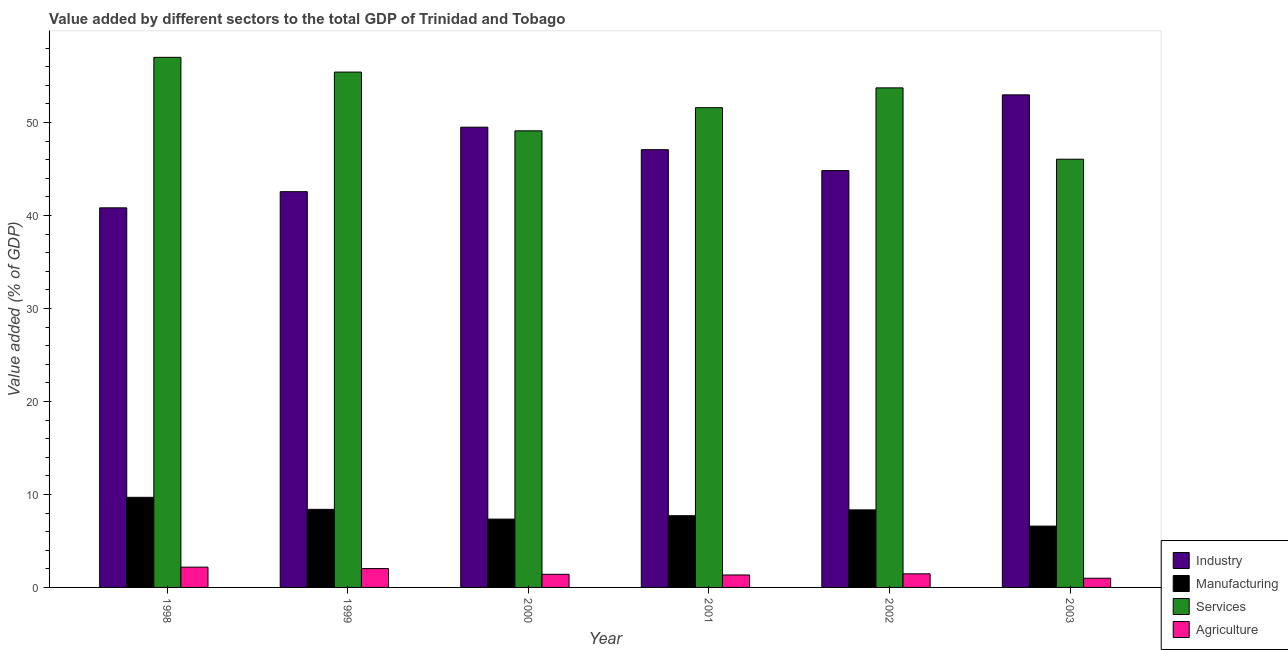How many different coloured bars are there?
Provide a succinct answer. 4. How many groups of bars are there?
Offer a very short reply. 6. Are the number of bars per tick equal to the number of legend labels?
Your response must be concise. Yes. Are the number of bars on each tick of the X-axis equal?
Your response must be concise. Yes. How many bars are there on the 3rd tick from the left?
Provide a succinct answer. 4. How many bars are there on the 3rd tick from the right?
Keep it short and to the point. 4. What is the label of the 1st group of bars from the left?
Your answer should be very brief. 1998. In how many cases, is the number of bars for a given year not equal to the number of legend labels?
Give a very brief answer. 0. What is the value added by agricultural sector in 1998?
Keep it short and to the point. 2.18. Across all years, what is the maximum value added by manufacturing sector?
Give a very brief answer. 9.69. Across all years, what is the minimum value added by services sector?
Give a very brief answer. 46.05. What is the total value added by manufacturing sector in the graph?
Provide a short and direct response. 48.08. What is the difference between the value added by agricultural sector in 2000 and that in 2002?
Your answer should be compact. -0.05. What is the difference between the value added by manufacturing sector in 2001 and the value added by services sector in 2000?
Provide a succinct answer. 0.37. What is the average value added by agricultural sector per year?
Offer a terse response. 1.57. In how many years, is the value added by agricultural sector greater than 34 %?
Offer a terse response. 0. What is the ratio of the value added by services sector in 1999 to that in 2003?
Keep it short and to the point. 1.2. Is the value added by industrial sector in 1999 less than that in 2001?
Your answer should be compact. Yes. What is the difference between the highest and the second highest value added by industrial sector?
Ensure brevity in your answer.  3.48. What is the difference between the highest and the lowest value added by services sector?
Provide a succinct answer. 10.96. Is it the case that in every year, the sum of the value added by industrial sector and value added by manufacturing sector is greater than the sum of value added by services sector and value added by agricultural sector?
Your answer should be very brief. Yes. What does the 1st bar from the left in 1998 represents?
Keep it short and to the point. Industry. What does the 3rd bar from the right in 1998 represents?
Ensure brevity in your answer.  Manufacturing. Is it the case that in every year, the sum of the value added by industrial sector and value added by manufacturing sector is greater than the value added by services sector?
Ensure brevity in your answer.  No. How many bars are there?
Keep it short and to the point. 24. Are all the bars in the graph horizontal?
Give a very brief answer. No. How many years are there in the graph?
Your response must be concise. 6. Are the values on the major ticks of Y-axis written in scientific E-notation?
Your answer should be very brief. No. Does the graph contain any zero values?
Offer a very short reply. No. Does the graph contain grids?
Give a very brief answer. No. How are the legend labels stacked?
Make the answer very short. Vertical. What is the title of the graph?
Your answer should be compact. Value added by different sectors to the total GDP of Trinidad and Tobago. What is the label or title of the Y-axis?
Provide a short and direct response. Value added (% of GDP). What is the Value added (% of GDP) in Industry in 1998?
Make the answer very short. 40.82. What is the Value added (% of GDP) in Manufacturing in 1998?
Offer a very short reply. 9.69. What is the Value added (% of GDP) of Services in 1998?
Your response must be concise. 57. What is the Value added (% of GDP) of Agriculture in 1998?
Keep it short and to the point. 2.18. What is the Value added (% of GDP) of Industry in 1999?
Your answer should be very brief. 42.56. What is the Value added (% of GDP) of Manufacturing in 1999?
Ensure brevity in your answer.  8.4. What is the Value added (% of GDP) of Services in 1999?
Give a very brief answer. 55.42. What is the Value added (% of GDP) of Agriculture in 1999?
Offer a very short reply. 2.03. What is the Value added (% of GDP) in Industry in 2000?
Your answer should be very brief. 49.49. What is the Value added (% of GDP) in Manufacturing in 2000?
Ensure brevity in your answer.  7.35. What is the Value added (% of GDP) of Services in 2000?
Your answer should be compact. 49.1. What is the Value added (% of GDP) of Agriculture in 2000?
Ensure brevity in your answer.  1.41. What is the Value added (% of GDP) in Industry in 2001?
Make the answer very short. 47.07. What is the Value added (% of GDP) of Manufacturing in 2001?
Offer a very short reply. 7.71. What is the Value added (% of GDP) of Services in 2001?
Provide a short and direct response. 51.59. What is the Value added (% of GDP) in Agriculture in 2001?
Your answer should be compact. 1.34. What is the Value added (% of GDP) of Industry in 2002?
Offer a terse response. 44.82. What is the Value added (% of GDP) of Manufacturing in 2002?
Your answer should be very brief. 8.34. What is the Value added (% of GDP) of Services in 2002?
Make the answer very short. 53.72. What is the Value added (% of GDP) in Agriculture in 2002?
Provide a succinct answer. 1.46. What is the Value added (% of GDP) in Industry in 2003?
Ensure brevity in your answer.  52.97. What is the Value added (% of GDP) in Manufacturing in 2003?
Keep it short and to the point. 6.59. What is the Value added (% of GDP) in Services in 2003?
Your answer should be very brief. 46.05. What is the Value added (% of GDP) in Agriculture in 2003?
Keep it short and to the point. 0.99. Across all years, what is the maximum Value added (% of GDP) of Industry?
Offer a terse response. 52.97. Across all years, what is the maximum Value added (% of GDP) of Manufacturing?
Your answer should be very brief. 9.69. Across all years, what is the maximum Value added (% of GDP) of Services?
Keep it short and to the point. 57. Across all years, what is the maximum Value added (% of GDP) in Agriculture?
Make the answer very short. 2.18. Across all years, what is the minimum Value added (% of GDP) in Industry?
Provide a succinct answer. 40.82. Across all years, what is the minimum Value added (% of GDP) of Manufacturing?
Your answer should be very brief. 6.59. Across all years, what is the minimum Value added (% of GDP) in Services?
Provide a succinct answer. 46.05. Across all years, what is the minimum Value added (% of GDP) of Agriculture?
Ensure brevity in your answer.  0.99. What is the total Value added (% of GDP) in Industry in the graph?
Make the answer very short. 277.72. What is the total Value added (% of GDP) in Manufacturing in the graph?
Keep it short and to the point. 48.08. What is the total Value added (% of GDP) of Services in the graph?
Your answer should be very brief. 312.87. What is the total Value added (% of GDP) in Agriculture in the graph?
Make the answer very short. 9.41. What is the difference between the Value added (% of GDP) in Industry in 1998 and that in 1999?
Your answer should be compact. -1.74. What is the difference between the Value added (% of GDP) in Manufacturing in 1998 and that in 1999?
Your response must be concise. 1.29. What is the difference between the Value added (% of GDP) in Services in 1998 and that in 1999?
Offer a terse response. 1.59. What is the difference between the Value added (% of GDP) in Agriculture in 1998 and that in 1999?
Your answer should be very brief. 0.15. What is the difference between the Value added (% of GDP) of Industry in 1998 and that in 2000?
Keep it short and to the point. -8.67. What is the difference between the Value added (% of GDP) in Manufacturing in 1998 and that in 2000?
Offer a very short reply. 2.34. What is the difference between the Value added (% of GDP) in Services in 1998 and that in 2000?
Give a very brief answer. 7.9. What is the difference between the Value added (% of GDP) in Agriculture in 1998 and that in 2000?
Your answer should be very brief. 0.77. What is the difference between the Value added (% of GDP) in Industry in 1998 and that in 2001?
Your answer should be very brief. -6.25. What is the difference between the Value added (% of GDP) in Manufacturing in 1998 and that in 2001?
Your answer should be compact. 1.98. What is the difference between the Value added (% of GDP) in Services in 1998 and that in 2001?
Make the answer very short. 5.41. What is the difference between the Value added (% of GDP) of Agriculture in 1998 and that in 2001?
Your answer should be very brief. 0.84. What is the difference between the Value added (% of GDP) of Industry in 1998 and that in 2002?
Provide a succinct answer. -4. What is the difference between the Value added (% of GDP) in Manufacturing in 1998 and that in 2002?
Make the answer very short. 1.35. What is the difference between the Value added (% of GDP) of Services in 1998 and that in 2002?
Provide a succinct answer. 3.28. What is the difference between the Value added (% of GDP) of Agriculture in 1998 and that in 2002?
Give a very brief answer. 0.72. What is the difference between the Value added (% of GDP) in Industry in 1998 and that in 2003?
Keep it short and to the point. -12.15. What is the difference between the Value added (% of GDP) of Manufacturing in 1998 and that in 2003?
Ensure brevity in your answer.  3.09. What is the difference between the Value added (% of GDP) of Services in 1998 and that in 2003?
Make the answer very short. 10.96. What is the difference between the Value added (% of GDP) in Agriculture in 1998 and that in 2003?
Your answer should be very brief. 1.19. What is the difference between the Value added (% of GDP) of Industry in 1999 and that in 2000?
Your answer should be very brief. -6.93. What is the difference between the Value added (% of GDP) in Manufacturing in 1999 and that in 2000?
Provide a succinct answer. 1.05. What is the difference between the Value added (% of GDP) of Services in 1999 and that in 2000?
Provide a succinct answer. 6.32. What is the difference between the Value added (% of GDP) in Agriculture in 1999 and that in 2000?
Make the answer very short. 0.61. What is the difference between the Value added (% of GDP) in Industry in 1999 and that in 2001?
Ensure brevity in your answer.  -4.51. What is the difference between the Value added (% of GDP) in Manufacturing in 1999 and that in 2001?
Make the answer very short. 0.68. What is the difference between the Value added (% of GDP) of Services in 1999 and that in 2001?
Your answer should be compact. 3.83. What is the difference between the Value added (% of GDP) in Agriculture in 1999 and that in 2001?
Your answer should be compact. 0.69. What is the difference between the Value added (% of GDP) of Industry in 1999 and that in 2002?
Your answer should be very brief. -2.26. What is the difference between the Value added (% of GDP) of Manufacturing in 1999 and that in 2002?
Offer a terse response. 0.06. What is the difference between the Value added (% of GDP) of Services in 1999 and that in 2002?
Offer a very short reply. 1.7. What is the difference between the Value added (% of GDP) in Agriculture in 1999 and that in 2002?
Your response must be concise. 0.57. What is the difference between the Value added (% of GDP) of Industry in 1999 and that in 2003?
Keep it short and to the point. -10.41. What is the difference between the Value added (% of GDP) of Manufacturing in 1999 and that in 2003?
Offer a very short reply. 1.8. What is the difference between the Value added (% of GDP) in Services in 1999 and that in 2003?
Your response must be concise. 9.37. What is the difference between the Value added (% of GDP) of Agriculture in 1999 and that in 2003?
Your response must be concise. 1.04. What is the difference between the Value added (% of GDP) of Industry in 2000 and that in 2001?
Make the answer very short. 2.42. What is the difference between the Value added (% of GDP) in Manufacturing in 2000 and that in 2001?
Provide a short and direct response. -0.37. What is the difference between the Value added (% of GDP) of Services in 2000 and that in 2001?
Keep it short and to the point. -2.49. What is the difference between the Value added (% of GDP) in Agriculture in 2000 and that in 2001?
Ensure brevity in your answer.  0.07. What is the difference between the Value added (% of GDP) of Industry in 2000 and that in 2002?
Your response must be concise. 4.67. What is the difference between the Value added (% of GDP) in Manufacturing in 2000 and that in 2002?
Offer a very short reply. -0.99. What is the difference between the Value added (% of GDP) in Services in 2000 and that in 2002?
Provide a short and direct response. -4.62. What is the difference between the Value added (% of GDP) in Agriculture in 2000 and that in 2002?
Make the answer very short. -0.05. What is the difference between the Value added (% of GDP) in Industry in 2000 and that in 2003?
Your answer should be very brief. -3.48. What is the difference between the Value added (% of GDP) of Manufacturing in 2000 and that in 2003?
Provide a succinct answer. 0.75. What is the difference between the Value added (% of GDP) of Services in 2000 and that in 2003?
Your answer should be compact. 3.05. What is the difference between the Value added (% of GDP) of Agriculture in 2000 and that in 2003?
Offer a terse response. 0.43. What is the difference between the Value added (% of GDP) in Industry in 2001 and that in 2002?
Provide a succinct answer. 2.25. What is the difference between the Value added (% of GDP) in Manufacturing in 2001 and that in 2002?
Your answer should be compact. -0.63. What is the difference between the Value added (% of GDP) in Services in 2001 and that in 2002?
Your response must be concise. -2.13. What is the difference between the Value added (% of GDP) in Agriculture in 2001 and that in 2002?
Ensure brevity in your answer.  -0.12. What is the difference between the Value added (% of GDP) of Industry in 2001 and that in 2003?
Your answer should be compact. -5.9. What is the difference between the Value added (% of GDP) of Manufacturing in 2001 and that in 2003?
Make the answer very short. 1.12. What is the difference between the Value added (% of GDP) in Services in 2001 and that in 2003?
Keep it short and to the point. 5.54. What is the difference between the Value added (% of GDP) in Agriculture in 2001 and that in 2003?
Your response must be concise. 0.35. What is the difference between the Value added (% of GDP) of Industry in 2002 and that in 2003?
Ensure brevity in your answer.  -8.15. What is the difference between the Value added (% of GDP) in Manufacturing in 2002 and that in 2003?
Keep it short and to the point. 1.75. What is the difference between the Value added (% of GDP) of Services in 2002 and that in 2003?
Provide a short and direct response. 7.67. What is the difference between the Value added (% of GDP) of Agriculture in 2002 and that in 2003?
Offer a terse response. 0.47. What is the difference between the Value added (% of GDP) of Industry in 1998 and the Value added (% of GDP) of Manufacturing in 1999?
Your answer should be very brief. 32.42. What is the difference between the Value added (% of GDP) in Industry in 1998 and the Value added (% of GDP) in Services in 1999?
Your response must be concise. -14.6. What is the difference between the Value added (% of GDP) of Industry in 1998 and the Value added (% of GDP) of Agriculture in 1999?
Your answer should be compact. 38.79. What is the difference between the Value added (% of GDP) in Manufacturing in 1998 and the Value added (% of GDP) in Services in 1999?
Provide a short and direct response. -45.73. What is the difference between the Value added (% of GDP) of Manufacturing in 1998 and the Value added (% of GDP) of Agriculture in 1999?
Keep it short and to the point. 7.66. What is the difference between the Value added (% of GDP) in Services in 1998 and the Value added (% of GDP) in Agriculture in 1999?
Provide a short and direct response. 54.97. What is the difference between the Value added (% of GDP) of Industry in 1998 and the Value added (% of GDP) of Manufacturing in 2000?
Offer a very short reply. 33.47. What is the difference between the Value added (% of GDP) of Industry in 1998 and the Value added (% of GDP) of Services in 2000?
Keep it short and to the point. -8.28. What is the difference between the Value added (% of GDP) of Industry in 1998 and the Value added (% of GDP) of Agriculture in 2000?
Your response must be concise. 39.4. What is the difference between the Value added (% of GDP) of Manufacturing in 1998 and the Value added (% of GDP) of Services in 2000?
Your response must be concise. -39.41. What is the difference between the Value added (% of GDP) in Manufacturing in 1998 and the Value added (% of GDP) in Agriculture in 2000?
Make the answer very short. 8.28. What is the difference between the Value added (% of GDP) in Services in 1998 and the Value added (% of GDP) in Agriculture in 2000?
Your response must be concise. 55.59. What is the difference between the Value added (% of GDP) of Industry in 1998 and the Value added (% of GDP) of Manufacturing in 2001?
Your answer should be very brief. 33.1. What is the difference between the Value added (% of GDP) in Industry in 1998 and the Value added (% of GDP) in Services in 2001?
Make the answer very short. -10.77. What is the difference between the Value added (% of GDP) in Industry in 1998 and the Value added (% of GDP) in Agriculture in 2001?
Make the answer very short. 39.48. What is the difference between the Value added (% of GDP) of Manufacturing in 1998 and the Value added (% of GDP) of Services in 2001?
Keep it short and to the point. -41.9. What is the difference between the Value added (% of GDP) of Manufacturing in 1998 and the Value added (% of GDP) of Agriculture in 2001?
Your response must be concise. 8.35. What is the difference between the Value added (% of GDP) in Services in 1998 and the Value added (% of GDP) in Agriculture in 2001?
Make the answer very short. 55.66. What is the difference between the Value added (% of GDP) of Industry in 1998 and the Value added (% of GDP) of Manufacturing in 2002?
Your answer should be compact. 32.48. What is the difference between the Value added (% of GDP) of Industry in 1998 and the Value added (% of GDP) of Services in 2002?
Keep it short and to the point. -12.9. What is the difference between the Value added (% of GDP) of Industry in 1998 and the Value added (% of GDP) of Agriculture in 2002?
Provide a succinct answer. 39.36. What is the difference between the Value added (% of GDP) in Manufacturing in 1998 and the Value added (% of GDP) in Services in 2002?
Ensure brevity in your answer.  -44.03. What is the difference between the Value added (% of GDP) in Manufacturing in 1998 and the Value added (% of GDP) in Agriculture in 2002?
Keep it short and to the point. 8.23. What is the difference between the Value added (% of GDP) in Services in 1998 and the Value added (% of GDP) in Agriculture in 2002?
Offer a very short reply. 55.54. What is the difference between the Value added (% of GDP) in Industry in 1998 and the Value added (% of GDP) in Manufacturing in 2003?
Keep it short and to the point. 34.22. What is the difference between the Value added (% of GDP) in Industry in 1998 and the Value added (% of GDP) in Services in 2003?
Your answer should be compact. -5.23. What is the difference between the Value added (% of GDP) of Industry in 1998 and the Value added (% of GDP) of Agriculture in 2003?
Provide a short and direct response. 39.83. What is the difference between the Value added (% of GDP) in Manufacturing in 1998 and the Value added (% of GDP) in Services in 2003?
Make the answer very short. -36.36. What is the difference between the Value added (% of GDP) of Manufacturing in 1998 and the Value added (% of GDP) of Agriculture in 2003?
Offer a very short reply. 8.7. What is the difference between the Value added (% of GDP) in Services in 1998 and the Value added (% of GDP) in Agriculture in 2003?
Your response must be concise. 56.01. What is the difference between the Value added (% of GDP) in Industry in 1999 and the Value added (% of GDP) in Manufacturing in 2000?
Offer a very short reply. 35.21. What is the difference between the Value added (% of GDP) of Industry in 1999 and the Value added (% of GDP) of Services in 2000?
Give a very brief answer. -6.54. What is the difference between the Value added (% of GDP) of Industry in 1999 and the Value added (% of GDP) of Agriculture in 2000?
Your answer should be very brief. 41.14. What is the difference between the Value added (% of GDP) of Manufacturing in 1999 and the Value added (% of GDP) of Services in 2000?
Your answer should be compact. -40.7. What is the difference between the Value added (% of GDP) in Manufacturing in 1999 and the Value added (% of GDP) in Agriculture in 2000?
Make the answer very short. 6.98. What is the difference between the Value added (% of GDP) of Services in 1999 and the Value added (% of GDP) of Agriculture in 2000?
Your answer should be very brief. 54. What is the difference between the Value added (% of GDP) in Industry in 1999 and the Value added (% of GDP) in Manufacturing in 2001?
Provide a succinct answer. 34.84. What is the difference between the Value added (% of GDP) in Industry in 1999 and the Value added (% of GDP) in Services in 2001?
Your answer should be compact. -9.03. What is the difference between the Value added (% of GDP) in Industry in 1999 and the Value added (% of GDP) in Agriculture in 2001?
Provide a short and direct response. 41.22. What is the difference between the Value added (% of GDP) in Manufacturing in 1999 and the Value added (% of GDP) in Services in 2001?
Offer a very short reply. -43.19. What is the difference between the Value added (% of GDP) of Manufacturing in 1999 and the Value added (% of GDP) of Agriculture in 2001?
Provide a succinct answer. 7.06. What is the difference between the Value added (% of GDP) of Services in 1999 and the Value added (% of GDP) of Agriculture in 2001?
Your answer should be compact. 54.08. What is the difference between the Value added (% of GDP) in Industry in 1999 and the Value added (% of GDP) in Manufacturing in 2002?
Provide a short and direct response. 34.22. What is the difference between the Value added (% of GDP) of Industry in 1999 and the Value added (% of GDP) of Services in 2002?
Ensure brevity in your answer.  -11.16. What is the difference between the Value added (% of GDP) of Industry in 1999 and the Value added (% of GDP) of Agriculture in 2002?
Offer a very short reply. 41.1. What is the difference between the Value added (% of GDP) of Manufacturing in 1999 and the Value added (% of GDP) of Services in 2002?
Give a very brief answer. -45.32. What is the difference between the Value added (% of GDP) in Manufacturing in 1999 and the Value added (% of GDP) in Agriculture in 2002?
Make the answer very short. 6.93. What is the difference between the Value added (% of GDP) of Services in 1999 and the Value added (% of GDP) of Agriculture in 2002?
Ensure brevity in your answer.  53.95. What is the difference between the Value added (% of GDP) in Industry in 1999 and the Value added (% of GDP) in Manufacturing in 2003?
Provide a short and direct response. 35.96. What is the difference between the Value added (% of GDP) of Industry in 1999 and the Value added (% of GDP) of Services in 2003?
Provide a short and direct response. -3.49. What is the difference between the Value added (% of GDP) of Industry in 1999 and the Value added (% of GDP) of Agriculture in 2003?
Provide a short and direct response. 41.57. What is the difference between the Value added (% of GDP) of Manufacturing in 1999 and the Value added (% of GDP) of Services in 2003?
Your answer should be compact. -37.65. What is the difference between the Value added (% of GDP) in Manufacturing in 1999 and the Value added (% of GDP) in Agriculture in 2003?
Provide a succinct answer. 7.41. What is the difference between the Value added (% of GDP) of Services in 1999 and the Value added (% of GDP) of Agriculture in 2003?
Provide a succinct answer. 54.43. What is the difference between the Value added (% of GDP) of Industry in 2000 and the Value added (% of GDP) of Manufacturing in 2001?
Provide a short and direct response. 41.78. What is the difference between the Value added (% of GDP) of Industry in 2000 and the Value added (% of GDP) of Services in 2001?
Offer a terse response. -2.1. What is the difference between the Value added (% of GDP) of Industry in 2000 and the Value added (% of GDP) of Agriculture in 2001?
Ensure brevity in your answer.  48.15. What is the difference between the Value added (% of GDP) in Manufacturing in 2000 and the Value added (% of GDP) in Services in 2001?
Provide a short and direct response. -44.24. What is the difference between the Value added (% of GDP) of Manufacturing in 2000 and the Value added (% of GDP) of Agriculture in 2001?
Give a very brief answer. 6.01. What is the difference between the Value added (% of GDP) of Services in 2000 and the Value added (% of GDP) of Agriculture in 2001?
Provide a short and direct response. 47.76. What is the difference between the Value added (% of GDP) of Industry in 2000 and the Value added (% of GDP) of Manufacturing in 2002?
Make the answer very short. 41.15. What is the difference between the Value added (% of GDP) of Industry in 2000 and the Value added (% of GDP) of Services in 2002?
Offer a terse response. -4.23. What is the difference between the Value added (% of GDP) in Industry in 2000 and the Value added (% of GDP) in Agriculture in 2002?
Ensure brevity in your answer.  48.03. What is the difference between the Value added (% of GDP) in Manufacturing in 2000 and the Value added (% of GDP) in Services in 2002?
Your answer should be very brief. -46.37. What is the difference between the Value added (% of GDP) in Manufacturing in 2000 and the Value added (% of GDP) in Agriculture in 2002?
Offer a terse response. 5.89. What is the difference between the Value added (% of GDP) in Services in 2000 and the Value added (% of GDP) in Agriculture in 2002?
Offer a very short reply. 47.64. What is the difference between the Value added (% of GDP) of Industry in 2000 and the Value added (% of GDP) of Manufacturing in 2003?
Make the answer very short. 42.9. What is the difference between the Value added (% of GDP) in Industry in 2000 and the Value added (% of GDP) in Services in 2003?
Your response must be concise. 3.44. What is the difference between the Value added (% of GDP) of Industry in 2000 and the Value added (% of GDP) of Agriculture in 2003?
Your response must be concise. 48.5. What is the difference between the Value added (% of GDP) in Manufacturing in 2000 and the Value added (% of GDP) in Services in 2003?
Give a very brief answer. -38.7. What is the difference between the Value added (% of GDP) of Manufacturing in 2000 and the Value added (% of GDP) of Agriculture in 2003?
Your answer should be compact. 6.36. What is the difference between the Value added (% of GDP) of Services in 2000 and the Value added (% of GDP) of Agriculture in 2003?
Your answer should be very brief. 48.11. What is the difference between the Value added (% of GDP) in Industry in 2001 and the Value added (% of GDP) in Manufacturing in 2002?
Offer a terse response. 38.73. What is the difference between the Value added (% of GDP) of Industry in 2001 and the Value added (% of GDP) of Services in 2002?
Keep it short and to the point. -6.65. What is the difference between the Value added (% of GDP) in Industry in 2001 and the Value added (% of GDP) in Agriculture in 2002?
Keep it short and to the point. 45.61. What is the difference between the Value added (% of GDP) in Manufacturing in 2001 and the Value added (% of GDP) in Services in 2002?
Give a very brief answer. -46.01. What is the difference between the Value added (% of GDP) in Manufacturing in 2001 and the Value added (% of GDP) in Agriculture in 2002?
Provide a short and direct response. 6.25. What is the difference between the Value added (% of GDP) of Services in 2001 and the Value added (% of GDP) of Agriculture in 2002?
Offer a very short reply. 50.13. What is the difference between the Value added (% of GDP) in Industry in 2001 and the Value added (% of GDP) in Manufacturing in 2003?
Your answer should be compact. 40.48. What is the difference between the Value added (% of GDP) of Industry in 2001 and the Value added (% of GDP) of Services in 2003?
Give a very brief answer. 1.03. What is the difference between the Value added (% of GDP) of Industry in 2001 and the Value added (% of GDP) of Agriculture in 2003?
Offer a terse response. 46.08. What is the difference between the Value added (% of GDP) of Manufacturing in 2001 and the Value added (% of GDP) of Services in 2003?
Your answer should be very brief. -38.33. What is the difference between the Value added (% of GDP) in Manufacturing in 2001 and the Value added (% of GDP) in Agriculture in 2003?
Ensure brevity in your answer.  6.73. What is the difference between the Value added (% of GDP) of Services in 2001 and the Value added (% of GDP) of Agriculture in 2003?
Your response must be concise. 50.6. What is the difference between the Value added (% of GDP) of Industry in 2002 and the Value added (% of GDP) of Manufacturing in 2003?
Offer a terse response. 38.23. What is the difference between the Value added (% of GDP) of Industry in 2002 and the Value added (% of GDP) of Services in 2003?
Provide a succinct answer. -1.22. What is the difference between the Value added (% of GDP) in Industry in 2002 and the Value added (% of GDP) in Agriculture in 2003?
Your response must be concise. 43.83. What is the difference between the Value added (% of GDP) in Manufacturing in 2002 and the Value added (% of GDP) in Services in 2003?
Your response must be concise. -37.71. What is the difference between the Value added (% of GDP) in Manufacturing in 2002 and the Value added (% of GDP) in Agriculture in 2003?
Provide a succinct answer. 7.35. What is the difference between the Value added (% of GDP) in Services in 2002 and the Value added (% of GDP) in Agriculture in 2003?
Provide a succinct answer. 52.73. What is the average Value added (% of GDP) of Industry per year?
Offer a terse response. 46.29. What is the average Value added (% of GDP) in Manufacturing per year?
Offer a terse response. 8.01. What is the average Value added (% of GDP) in Services per year?
Keep it short and to the point. 52.14. What is the average Value added (% of GDP) in Agriculture per year?
Offer a terse response. 1.57. In the year 1998, what is the difference between the Value added (% of GDP) of Industry and Value added (% of GDP) of Manufacturing?
Make the answer very short. 31.13. In the year 1998, what is the difference between the Value added (% of GDP) in Industry and Value added (% of GDP) in Services?
Make the answer very short. -16.18. In the year 1998, what is the difference between the Value added (% of GDP) of Industry and Value added (% of GDP) of Agriculture?
Your answer should be very brief. 38.64. In the year 1998, what is the difference between the Value added (% of GDP) in Manufacturing and Value added (% of GDP) in Services?
Offer a very short reply. -47.31. In the year 1998, what is the difference between the Value added (% of GDP) of Manufacturing and Value added (% of GDP) of Agriculture?
Provide a succinct answer. 7.51. In the year 1998, what is the difference between the Value added (% of GDP) in Services and Value added (% of GDP) in Agriculture?
Provide a succinct answer. 54.82. In the year 1999, what is the difference between the Value added (% of GDP) in Industry and Value added (% of GDP) in Manufacturing?
Ensure brevity in your answer.  34.16. In the year 1999, what is the difference between the Value added (% of GDP) in Industry and Value added (% of GDP) in Services?
Ensure brevity in your answer.  -12.86. In the year 1999, what is the difference between the Value added (% of GDP) in Industry and Value added (% of GDP) in Agriculture?
Provide a short and direct response. 40.53. In the year 1999, what is the difference between the Value added (% of GDP) in Manufacturing and Value added (% of GDP) in Services?
Provide a short and direct response. -47.02. In the year 1999, what is the difference between the Value added (% of GDP) in Manufacturing and Value added (% of GDP) in Agriculture?
Make the answer very short. 6.37. In the year 1999, what is the difference between the Value added (% of GDP) in Services and Value added (% of GDP) in Agriculture?
Provide a short and direct response. 53.39. In the year 2000, what is the difference between the Value added (% of GDP) of Industry and Value added (% of GDP) of Manufacturing?
Ensure brevity in your answer.  42.14. In the year 2000, what is the difference between the Value added (% of GDP) in Industry and Value added (% of GDP) in Services?
Offer a terse response. 0.39. In the year 2000, what is the difference between the Value added (% of GDP) of Industry and Value added (% of GDP) of Agriculture?
Make the answer very short. 48.08. In the year 2000, what is the difference between the Value added (% of GDP) of Manufacturing and Value added (% of GDP) of Services?
Provide a succinct answer. -41.75. In the year 2000, what is the difference between the Value added (% of GDP) of Manufacturing and Value added (% of GDP) of Agriculture?
Give a very brief answer. 5.93. In the year 2000, what is the difference between the Value added (% of GDP) in Services and Value added (% of GDP) in Agriculture?
Provide a short and direct response. 47.69. In the year 2001, what is the difference between the Value added (% of GDP) of Industry and Value added (% of GDP) of Manufacturing?
Your answer should be compact. 39.36. In the year 2001, what is the difference between the Value added (% of GDP) of Industry and Value added (% of GDP) of Services?
Offer a very short reply. -4.52. In the year 2001, what is the difference between the Value added (% of GDP) in Industry and Value added (% of GDP) in Agriculture?
Provide a short and direct response. 45.73. In the year 2001, what is the difference between the Value added (% of GDP) of Manufacturing and Value added (% of GDP) of Services?
Keep it short and to the point. -43.88. In the year 2001, what is the difference between the Value added (% of GDP) of Manufacturing and Value added (% of GDP) of Agriculture?
Provide a short and direct response. 6.37. In the year 2001, what is the difference between the Value added (% of GDP) of Services and Value added (% of GDP) of Agriculture?
Keep it short and to the point. 50.25. In the year 2002, what is the difference between the Value added (% of GDP) of Industry and Value added (% of GDP) of Manufacturing?
Make the answer very short. 36.48. In the year 2002, what is the difference between the Value added (% of GDP) of Industry and Value added (% of GDP) of Services?
Offer a very short reply. -8.9. In the year 2002, what is the difference between the Value added (% of GDP) of Industry and Value added (% of GDP) of Agriculture?
Give a very brief answer. 43.36. In the year 2002, what is the difference between the Value added (% of GDP) of Manufacturing and Value added (% of GDP) of Services?
Offer a terse response. -45.38. In the year 2002, what is the difference between the Value added (% of GDP) of Manufacturing and Value added (% of GDP) of Agriculture?
Keep it short and to the point. 6.88. In the year 2002, what is the difference between the Value added (% of GDP) of Services and Value added (% of GDP) of Agriculture?
Provide a succinct answer. 52.26. In the year 2003, what is the difference between the Value added (% of GDP) in Industry and Value added (% of GDP) in Manufacturing?
Your answer should be very brief. 46.37. In the year 2003, what is the difference between the Value added (% of GDP) of Industry and Value added (% of GDP) of Services?
Your response must be concise. 6.92. In the year 2003, what is the difference between the Value added (% of GDP) in Industry and Value added (% of GDP) in Agriculture?
Your answer should be compact. 51.98. In the year 2003, what is the difference between the Value added (% of GDP) of Manufacturing and Value added (% of GDP) of Services?
Give a very brief answer. -39.45. In the year 2003, what is the difference between the Value added (% of GDP) of Manufacturing and Value added (% of GDP) of Agriculture?
Keep it short and to the point. 5.61. In the year 2003, what is the difference between the Value added (% of GDP) in Services and Value added (% of GDP) in Agriculture?
Your answer should be compact. 45.06. What is the ratio of the Value added (% of GDP) in Industry in 1998 to that in 1999?
Give a very brief answer. 0.96. What is the ratio of the Value added (% of GDP) in Manufacturing in 1998 to that in 1999?
Ensure brevity in your answer.  1.15. What is the ratio of the Value added (% of GDP) in Services in 1998 to that in 1999?
Ensure brevity in your answer.  1.03. What is the ratio of the Value added (% of GDP) in Agriculture in 1998 to that in 1999?
Provide a short and direct response. 1.08. What is the ratio of the Value added (% of GDP) in Industry in 1998 to that in 2000?
Offer a very short reply. 0.82. What is the ratio of the Value added (% of GDP) of Manufacturing in 1998 to that in 2000?
Your response must be concise. 1.32. What is the ratio of the Value added (% of GDP) in Services in 1998 to that in 2000?
Offer a terse response. 1.16. What is the ratio of the Value added (% of GDP) in Agriculture in 1998 to that in 2000?
Provide a succinct answer. 1.54. What is the ratio of the Value added (% of GDP) in Industry in 1998 to that in 2001?
Keep it short and to the point. 0.87. What is the ratio of the Value added (% of GDP) of Manufacturing in 1998 to that in 2001?
Offer a terse response. 1.26. What is the ratio of the Value added (% of GDP) of Services in 1998 to that in 2001?
Provide a succinct answer. 1.1. What is the ratio of the Value added (% of GDP) in Agriculture in 1998 to that in 2001?
Keep it short and to the point. 1.63. What is the ratio of the Value added (% of GDP) in Industry in 1998 to that in 2002?
Offer a very short reply. 0.91. What is the ratio of the Value added (% of GDP) in Manufacturing in 1998 to that in 2002?
Your response must be concise. 1.16. What is the ratio of the Value added (% of GDP) in Services in 1998 to that in 2002?
Give a very brief answer. 1.06. What is the ratio of the Value added (% of GDP) in Agriculture in 1998 to that in 2002?
Your response must be concise. 1.49. What is the ratio of the Value added (% of GDP) of Industry in 1998 to that in 2003?
Give a very brief answer. 0.77. What is the ratio of the Value added (% of GDP) of Manufacturing in 1998 to that in 2003?
Ensure brevity in your answer.  1.47. What is the ratio of the Value added (% of GDP) of Services in 1998 to that in 2003?
Keep it short and to the point. 1.24. What is the ratio of the Value added (% of GDP) in Agriculture in 1998 to that in 2003?
Ensure brevity in your answer.  2.21. What is the ratio of the Value added (% of GDP) of Industry in 1999 to that in 2000?
Ensure brevity in your answer.  0.86. What is the ratio of the Value added (% of GDP) of Manufacturing in 1999 to that in 2000?
Your answer should be compact. 1.14. What is the ratio of the Value added (% of GDP) of Services in 1999 to that in 2000?
Keep it short and to the point. 1.13. What is the ratio of the Value added (% of GDP) of Agriculture in 1999 to that in 2000?
Your answer should be very brief. 1.44. What is the ratio of the Value added (% of GDP) of Industry in 1999 to that in 2001?
Give a very brief answer. 0.9. What is the ratio of the Value added (% of GDP) in Manufacturing in 1999 to that in 2001?
Give a very brief answer. 1.09. What is the ratio of the Value added (% of GDP) of Services in 1999 to that in 2001?
Provide a short and direct response. 1.07. What is the ratio of the Value added (% of GDP) in Agriculture in 1999 to that in 2001?
Your response must be concise. 1.51. What is the ratio of the Value added (% of GDP) in Industry in 1999 to that in 2002?
Keep it short and to the point. 0.95. What is the ratio of the Value added (% of GDP) of Manufacturing in 1999 to that in 2002?
Offer a very short reply. 1.01. What is the ratio of the Value added (% of GDP) of Services in 1999 to that in 2002?
Your answer should be very brief. 1.03. What is the ratio of the Value added (% of GDP) of Agriculture in 1999 to that in 2002?
Give a very brief answer. 1.39. What is the ratio of the Value added (% of GDP) in Industry in 1999 to that in 2003?
Your response must be concise. 0.8. What is the ratio of the Value added (% of GDP) in Manufacturing in 1999 to that in 2003?
Your answer should be very brief. 1.27. What is the ratio of the Value added (% of GDP) of Services in 1999 to that in 2003?
Provide a short and direct response. 1.2. What is the ratio of the Value added (% of GDP) in Agriculture in 1999 to that in 2003?
Offer a very short reply. 2.06. What is the ratio of the Value added (% of GDP) in Industry in 2000 to that in 2001?
Ensure brevity in your answer.  1.05. What is the ratio of the Value added (% of GDP) of Manufacturing in 2000 to that in 2001?
Keep it short and to the point. 0.95. What is the ratio of the Value added (% of GDP) in Services in 2000 to that in 2001?
Your answer should be very brief. 0.95. What is the ratio of the Value added (% of GDP) of Agriculture in 2000 to that in 2001?
Keep it short and to the point. 1.05. What is the ratio of the Value added (% of GDP) in Industry in 2000 to that in 2002?
Make the answer very short. 1.1. What is the ratio of the Value added (% of GDP) of Manufacturing in 2000 to that in 2002?
Your answer should be compact. 0.88. What is the ratio of the Value added (% of GDP) of Services in 2000 to that in 2002?
Make the answer very short. 0.91. What is the ratio of the Value added (% of GDP) in Agriculture in 2000 to that in 2002?
Ensure brevity in your answer.  0.97. What is the ratio of the Value added (% of GDP) in Industry in 2000 to that in 2003?
Your answer should be very brief. 0.93. What is the ratio of the Value added (% of GDP) in Manufacturing in 2000 to that in 2003?
Provide a succinct answer. 1.11. What is the ratio of the Value added (% of GDP) in Services in 2000 to that in 2003?
Provide a short and direct response. 1.07. What is the ratio of the Value added (% of GDP) in Agriculture in 2000 to that in 2003?
Provide a short and direct response. 1.43. What is the ratio of the Value added (% of GDP) of Industry in 2001 to that in 2002?
Ensure brevity in your answer.  1.05. What is the ratio of the Value added (% of GDP) of Manufacturing in 2001 to that in 2002?
Offer a terse response. 0.92. What is the ratio of the Value added (% of GDP) in Services in 2001 to that in 2002?
Give a very brief answer. 0.96. What is the ratio of the Value added (% of GDP) of Agriculture in 2001 to that in 2002?
Offer a terse response. 0.92. What is the ratio of the Value added (% of GDP) in Industry in 2001 to that in 2003?
Make the answer very short. 0.89. What is the ratio of the Value added (% of GDP) of Manufacturing in 2001 to that in 2003?
Make the answer very short. 1.17. What is the ratio of the Value added (% of GDP) in Services in 2001 to that in 2003?
Your response must be concise. 1.12. What is the ratio of the Value added (% of GDP) in Agriculture in 2001 to that in 2003?
Provide a succinct answer. 1.36. What is the ratio of the Value added (% of GDP) in Industry in 2002 to that in 2003?
Make the answer very short. 0.85. What is the ratio of the Value added (% of GDP) in Manufacturing in 2002 to that in 2003?
Ensure brevity in your answer.  1.26. What is the ratio of the Value added (% of GDP) in Services in 2002 to that in 2003?
Your answer should be compact. 1.17. What is the ratio of the Value added (% of GDP) in Agriculture in 2002 to that in 2003?
Keep it short and to the point. 1.48. What is the difference between the highest and the second highest Value added (% of GDP) in Industry?
Your response must be concise. 3.48. What is the difference between the highest and the second highest Value added (% of GDP) of Manufacturing?
Your answer should be compact. 1.29. What is the difference between the highest and the second highest Value added (% of GDP) in Services?
Offer a terse response. 1.59. What is the difference between the highest and the second highest Value added (% of GDP) in Agriculture?
Ensure brevity in your answer.  0.15. What is the difference between the highest and the lowest Value added (% of GDP) in Industry?
Make the answer very short. 12.15. What is the difference between the highest and the lowest Value added (% of GDP) in Manufacturing?
Give a very brief answer. 3.09. What is the difference between the highest and the lowest Value added (% of GDP) of Services?
Keep it short and to the point. 10.96. What is the difference between the highest and the lowest Value added (% of GDP) in Agriculture?
Provide a succinct answer. 1.19. 